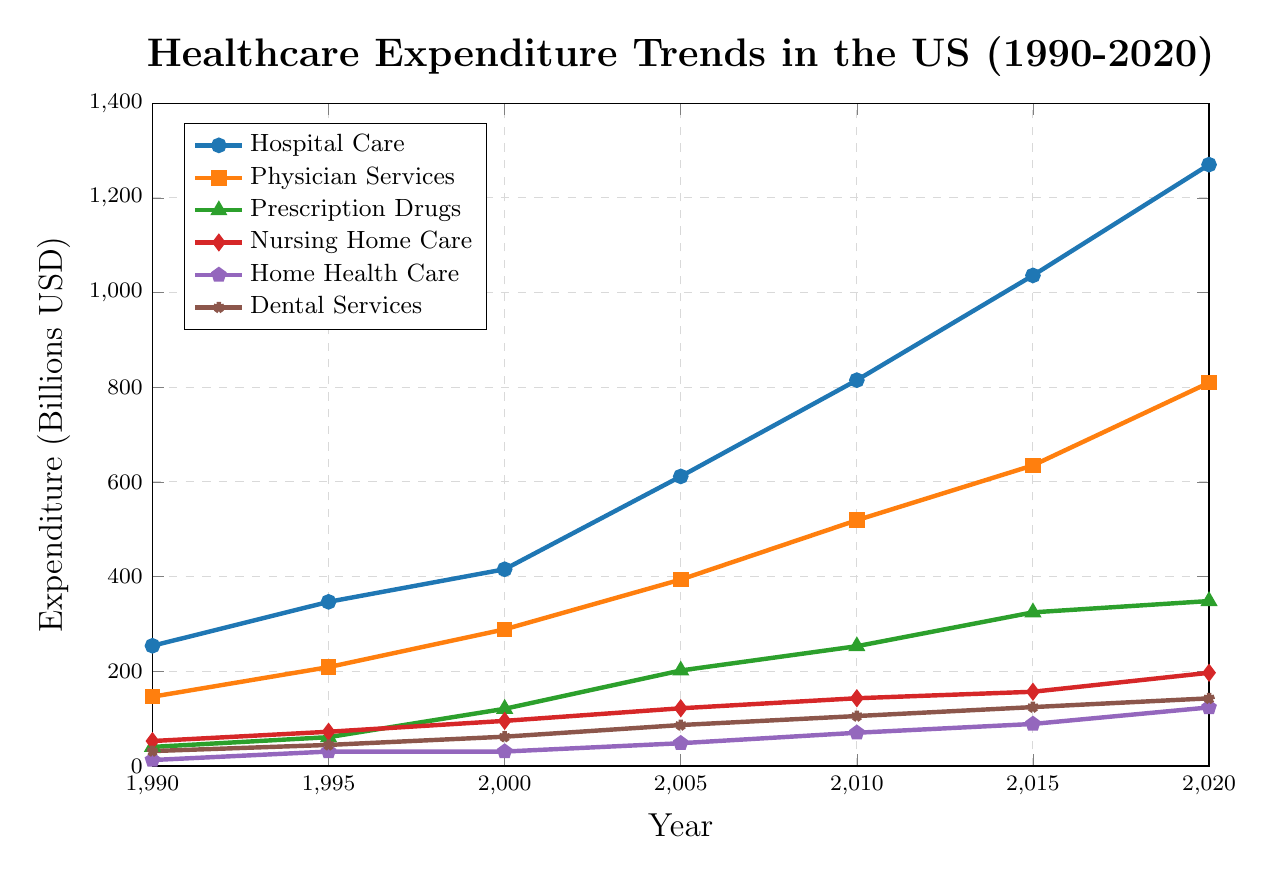What is the trend in healthcare expenditure for Hospital Care from 1990 to 2020? By observing the line representing Hospital Care, it can be seen that expenditure increases consistently over the years. The values rise from approximately 253.9 billion USD in 1990 to 1270.1 billion USD in 2020.
Answer: Upward trend Which service category had the highest expenditure in 2020? By looking at the endpoints of each line for the year 2020, it's clear that Hospital Care has the highest expenditure, reaching 1270.1 billion USD.
Answer: Hospital Care How much did the expenditure on Prescription Drugs increase from 1990 to 2000? The expenditure on Prescription Drugs in 1990 was 40.3 billion USD, and it increased to 120.8 billion USD by 2000. The increase is calculated as 120.8 - 40.3 = 80.5 billion USD.
Answer: 80.5 billion USD Compare the growth rate of Physician Services and Dental Services between 1990 and 2020. The expenditure on Physician Services in 1990 was 146.3 billion USD, increasing to 809.5 billion USD in 2020. For Dental Services, expenditure grew from 31.5 billion USD to 142.9 billion USD in the same period. The growth rates can be calculated using the formula [(final amount - initial amount) / initial amount] * 100:
- Physician Services: [(809.5 - 146.3) / 146.3] * 100 ≈ 453.2%
- Dental Services: [(142.9 - 31.5) / 31.5] * 100 ≈ 353.3%
Therefore, Physician Services experienced a higher growth rate than Dental Services.
Answer: Physician Services What was the expenditure on Home Health Care in 2000, and how does it compare to the expenditure in 1995 and 2005? The expenditure on Home Health Care did not change between 1995 (30.5 billion USD) and 2000 (30.5 billion USD). However, it increased to 48.1 billion USD by 2005.
- 1995: 30.5 billion USD
- 2000: 30.5 billion USD
- 2005: 48.1 billion USD
Thus, there was no change from 1995 to 2000, but an increase of 17.6 billion USD from 2000 to 2005.
Answer: No change from 1995 to 2000; 48.1 billion USD in 2005 What is the difference in expenditure between Nursing Home Care and Home Health Care in 2010? The expenditure on Nursing Home Care in 2010 was 143.1 billion USD, while for Home Health Care, it was 70.2 billion USD. The difference is calculated as 143.1 - 70.2 = 72.9 billion USD.
Answer: 72.9 billion USD Which service category saw the least absolute increase in expenditure from 1990 to 2020? By examining the data, Home Health Care increased from 12.6 billion USD in 1990 to 123.7 billion USD in 2020. The absolute increase is 123.7 - 12.6 = 111.1 billion USD. Checking other categories, Home Health Care has the least absolute increase compared to others.
Answer: Home Health Care 